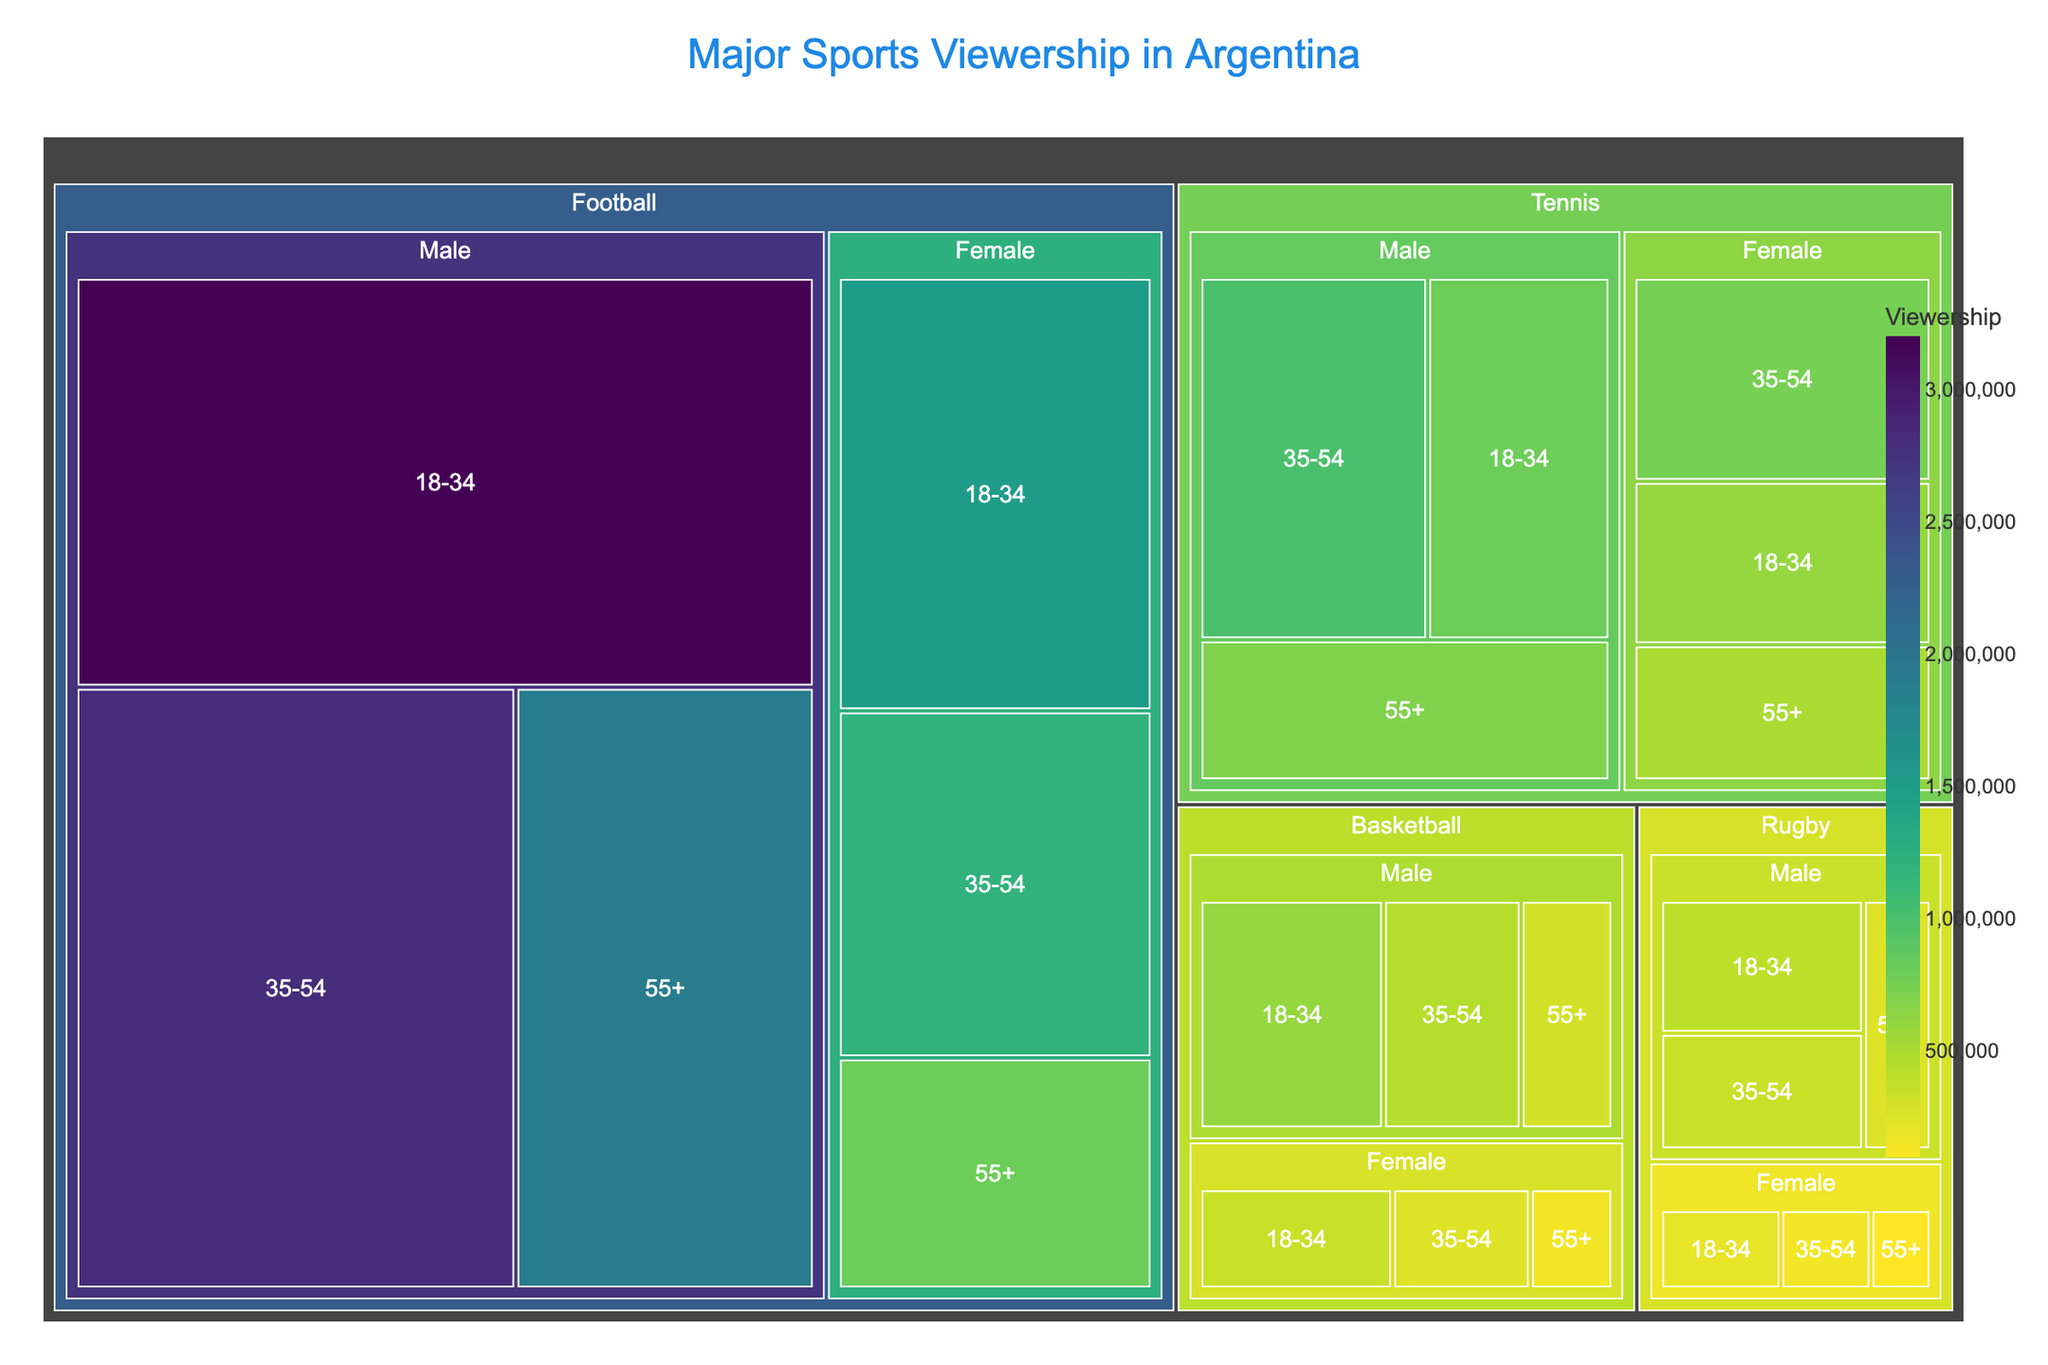What sport has the highest overall viewership? The treemap shows the overall viewership size by sport. Football has the largest sections, indicating it has the highest overall viewership.
Answer: Football Which age group among males has the highest viewership for tennis? Within the "Tennis" subsection for males, the "35-54" age group has the largest portion.
Answer: 35-54 What is the viewership for females aged 35-54 in basketball? Navigate to the "Basketball" section, find "Female," and then locate the "35-54" age group. The labeled viewership is 250,000.
Answer: 250,000 Compare the total viewership of rugby and basketball. Which is higher? Summing up the viewership for rugby and basketball for each demographic group and comparing totals, basketball has higher overall viewership.
Answer: Basketball Which sport and demographic combination has the lowest viewership? Navigate through each sport's demographic breakdown and find the smallest value, which is "Rugby, 55+, Female" with 100,000.
Answer: Rugby, 55+, Female Is the viewership for females aged 18-34 higher in tennis or rugby? Compare segments for "Tennis, Female, 18-34" (600,000) and "Rugby, Female, 18-34" (200,000). Tennis is higher.
Answer: Tennis What is the total viewership for football among females of all age groups? Sum up the viewership of "Football, Female, 18-34" (1,500,000), "Football, Female, 35-54" (1,200,000), and "Football, Female, 55+" (800,000). Total is 3,500,000.
Answer: 3,500,000 How does the viewership of tennis among males aged 55+ compare to basketball among the same group? Check the "Tennis, Male, 55+" (700,000) and compare it with "Basketball, Male, 55+" (300,000). Tennis is higher.
Answer: Tennis What is the largest age group of football viewers? Within the "Football" section, the "18-34" age group for males is the largest.
Answer: 18-34, Male Which sport has the largest female viewership in the 18-34 age group? Look at the largest viewership in the "18-34, Female" category. Football has the largest at 1,500,000.
Answer: Football 